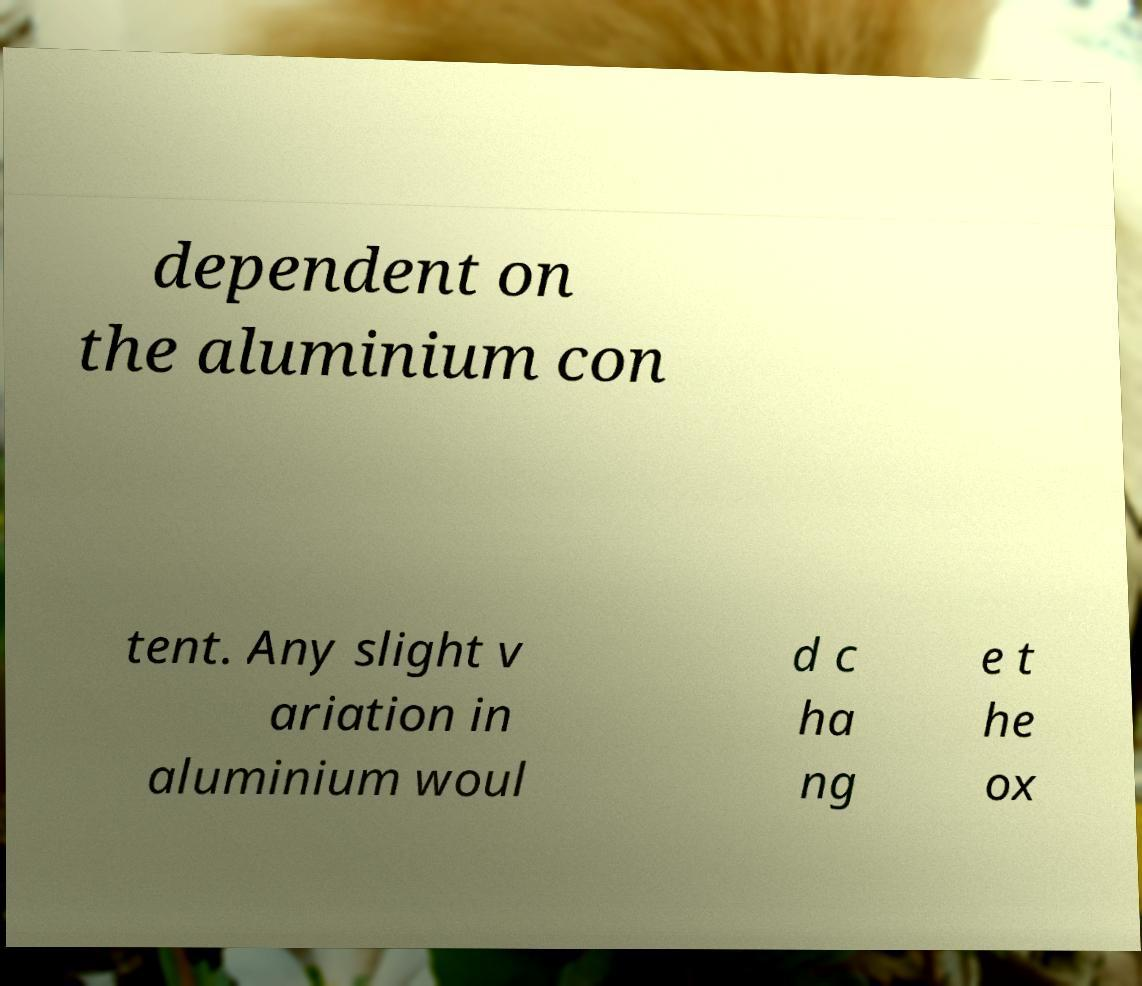Can you read and provide the text displayed in the image?This photo seems to have some interesting text. Can you extract and type it out for me? dependent on the aluminium con tent. Any slight v ariation in aluminium woul d c ha ng e t he ox 